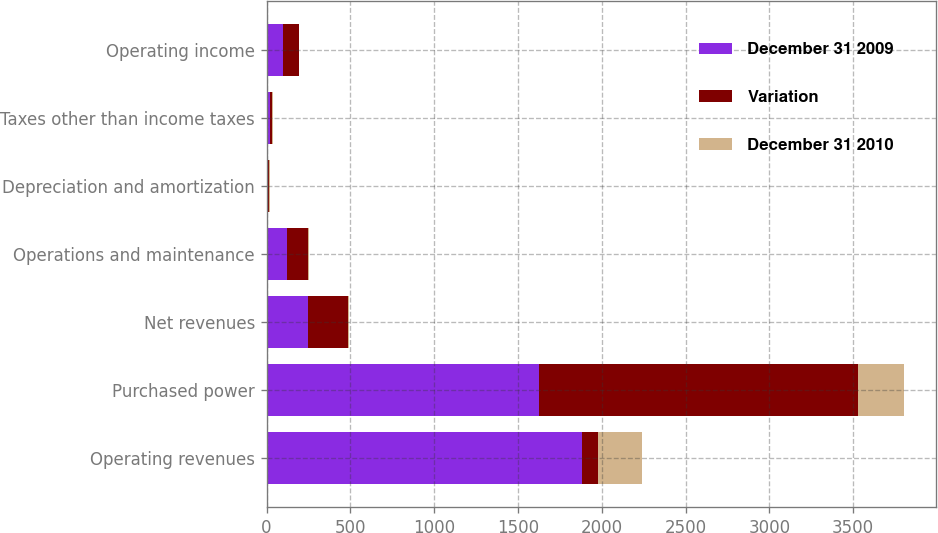<chart> <loc_0><loc_0><loc_500><loc_500><stacked_bar_chart><ecel><fcel>Operating revenues<fcel>Purchased power<fcel>Net revenues<fcel>Operations and maintenance<fcel>Depreciation and amortization<fcel>Taxes other than income taxes<fcel>Operating income<nl><fcel>December 31 2009<fcel>1883<fcel>1627<fcel>247<fcel>122<fcel>9<fcel>18<fcel>98<nl><fcel>Variation<fcel>96<fcel>1901<fcel>237<fcel>125<fcel>5<fcel>13<fcel>94<nl><fcel>December 31 2010<fcel>264<fcel>274<fcel>10<fcel>3<fcel>4<fcel>5<fcel>4<nl></chart> 